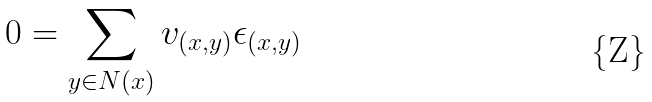<formula> <loc_0><loc_0><loc_500><loc_500>0 = \sum _ { y \in N ( x ) } v _ { ( x , y ) } \epsilon _ { ( x , y ) }</formula> 